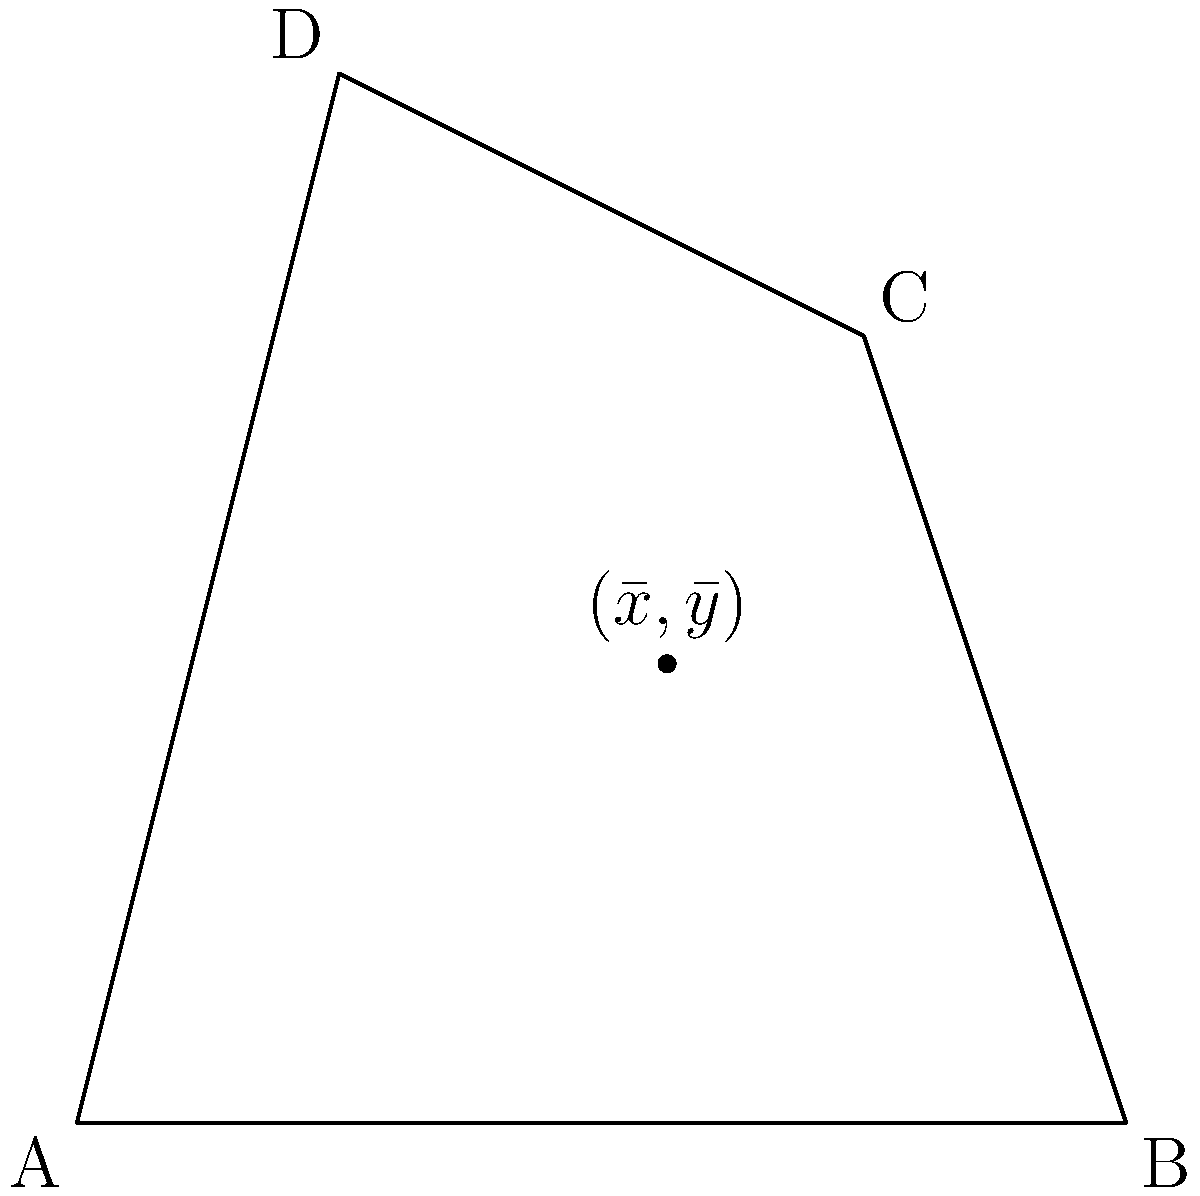Find the centroid $(\bar{x}, \bar{y})$ of the irregular quadrilateral lamina ABCD with vertices A(0,0), B(4,0), C(3,3), and D(1,4). Express your answer in terms of exact fractions. To find the centroid of an irregular lamina, we can use the following steps:

1) Divide the shape into triangles: ABC and ACD.

2) Find the area of each triangle:
   $A_{ABC} = \frac{1}{2}|4\cdot3 - 0\cdot3| = 6$
   $A_{ACD} = \frac{1}{2}|1\cdot3 - 3\cdot4| = 4.5$

3) Find the centroid of each triangle:
   Triangle ABC: $(\frac{0+4+3}{3}, \frac{0+0+3}{3}) = (\frac{7}{3}, 1)$
   Triangle ACD: $(\frac{0+3+1}{3}, \frac{0+3+4}{3}) = (\frac{4}{3}, \frac{7}{3})$

4) Use the formula for the centroid of a composite shape:
   $\bar{x} = \frac{\sum A_i x_i}{\sum A_i}$, $\bar{y} = \frac{\sum A_i y_i}{\sum A_i}$

   Where $A_i$ is the area of each part, and $(x_i, y_i)$ is the centroid of each part.

5) Calculate $\bar{x}$:
   $\bar{x} = \frac{6 \cdot \frac{7}{3} + 4.5 \cdot \frac{4}{3}}{6 + 4.5} = \frac{14 + 6}{10.5} = \frac{20}{10.5} = \frac{40}{21}$

6) Calculate $\bar{y}$:
   $\bar{y} = \frac{6 \cdot 1 + 4.5 \cdot \frac{7}{3}}{6 + 4.5} = \frac{6 + 10.5}{10.5} = \frac{16.5}{10.5} = \frac{11}{7}$

Therefore, the centroid is $(\frac{40}{21}, \frac{11}{7})$.
Answer: $(\frac{40}{21}, \frac{11}{7})$ 